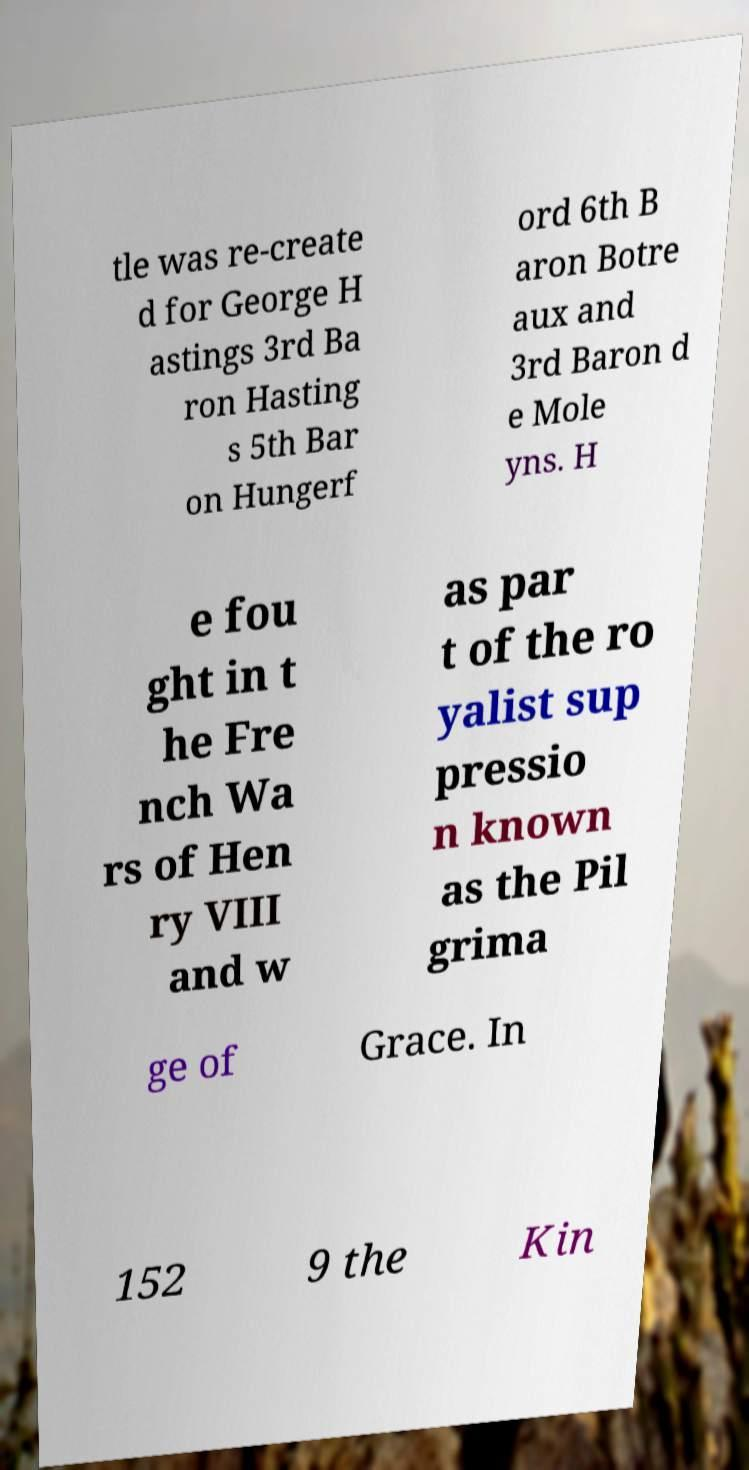For documentation purposes, I need the text within this image transcribed. Could you provide that? tle was re-create d for George H astings 3rd Ba ron Hasting s 5th Bar on Hungerf ord 6th B aron Botre aux and 3rd Baron d e Mole yns. H e fou ght in t he Fre nch Wa rs of Hen ry VIII and w as par t of the ro yalist sup pressio n known as the Pil grima ge of Grace. In 152 9 the Kin 